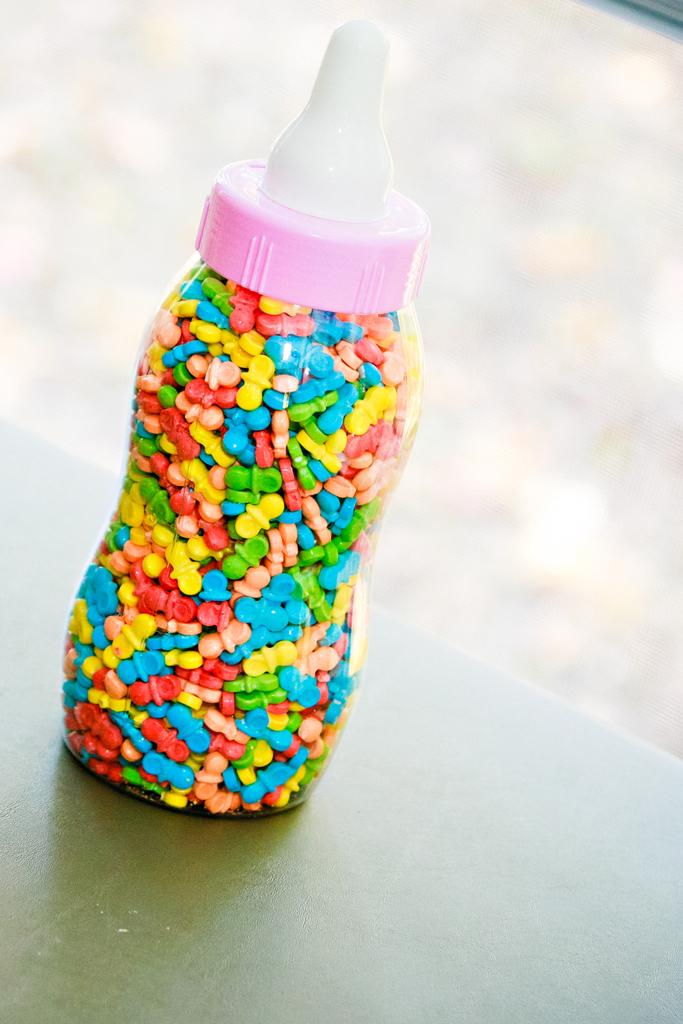What object is visible in the image? There is a bottle in the image. Where is the bottle located? The bottle is placed on a table. What type of eggs can be seen being used as a spade in the image? There are no eggs or spades present in the image. What company is responsible for manufacturing the bottle in the image? The provided facts do not mention any company responsible for manufacturing the bottle in the image. 